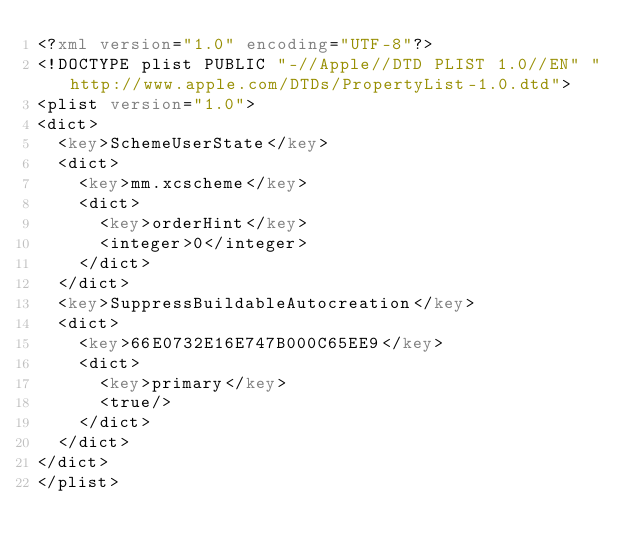Convert code to text. <code><loc_0><loc_0><loc_500><loc_500><_XML_><?xml version="1.0" encoding="UTF-8"?>
<!DOCTYPE plist PUBLIC "-//Apple//DTD PLIST 1.0//EN" "http://www.apple.com/DTDs/PropertyList-1.0.dtd">
<plist version="1.0">
<dict>
	<key>SchemeUserState</key>
	<dict>
		<key>mm.xcscheme</key>
		<dict>
			<key>orderHint</key>
			<integer>0</integer>
		</dict>
	</dict>
	<key>SuppressBuildableAutocreation</key>
	<dict>
		<key>66E0732E16E747B000C65EE9</key>
		<dict>
			<key>primary</key>
			<true/>
		</dict>
	</dict>
</dict>
</plist>
</code> 